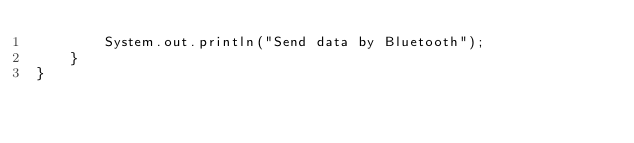<code> <loc_0><loc_0><loc_500><loc_500><_Java_>        System.out.println("Send data by Bluetooth");
    }
}
</code> 